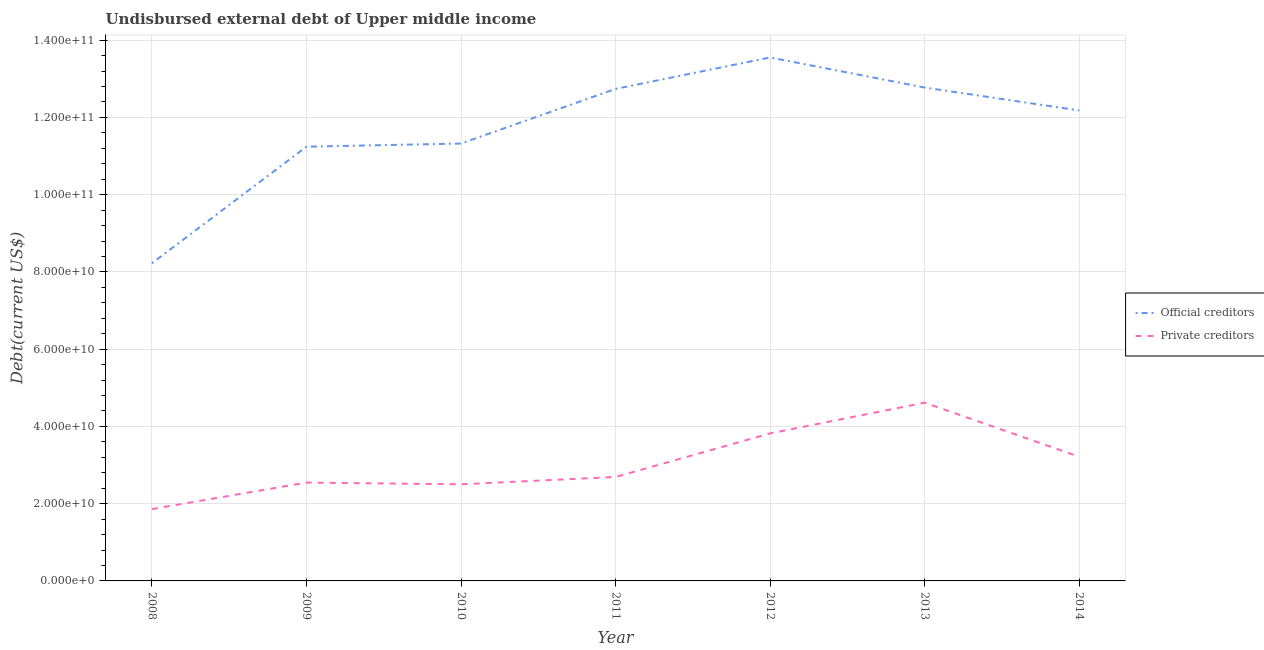What is the undisbursed external debt of official creditors in 2009?
Give a very brief answer. 1.12e+11. Across all years, what is the maximum undisbursed external debt of official creditors?
Offer a very short reply. 1.36e+11. Across all years, what is the minimum undisbursed external debt of private creditors?
Provide a short and direct response. 1.86e+1. In which year was the undisbursed external debt of official creditors maximum?
Your response must be concise. 2012. In which year was the undisbursed external debt of official creditors minimum?
Provide a succinct answer. 2008. What is the total undisbursed external debt of official creditors in the graph?
Give a very brief answer. 8.20e+11. What is the difference between the undisbursed external debt of official creditors in 2009 and that in 2013?
Make the answer very short. -1.53e+1. What is the difference between the undisbursed external debt of official creditors in 2012 and the undisbursed external debt of private creditors in 2008?
Your answer should be very brief. 1.17e+11. What is the average undisbursed external debt of private creditors per year?
Your response must be concise. 3.04e+1. In the year 2010, what is the difference between the undisbursed external debt of official creditors and undisbursed external debt of private creditors?
Your answer should be very brief. 8.82e+1. In how many years, is the undisbursed external debt of private creditors greater than 96000000000 US$?
Provide a short and direct response. 0. What is the ratio of the undisbursed external debt of official creditors in 2010 to that in 2014?
Offer a very short reply. 0.93. Is the difference between the undisbursed external debt of official creditors in 2011 and 2012 greater than the difference between the undisbursed external debt of private creditors in 2011 and 2012?
Ensure brevity in your answer.  Yes. What is the difference between the highest and the second highest undisbursed external debt of official creditors?
Ensure brevity in your answer.  7.79e+09. What is the difference between the highest and the lowest undisbursed external debt of official creditors?
Ensure brevity in your answer.  5.33e+1. Is the undisbursed external debt of official creditors strictly greater than the undisbursed external debt of private creditors over the years?
Keep it short and to the point. Yes. How many lines are there?
Your answer should be very brief. 2. How many years are there in the graph?
Make the answer very short. 7. What is the difference between two consecutive major ticks on the Y-axis?
Keep it short and to the point. 2.00e+1. Does the graph contain any zero values?
Make the answer very short. No. Does the graph contain grids?
Offer a very short reply. Yes. Where does the legend appear in the graph?
Your answer should be very brief. Center right. What is the title of the graph?
Your answer should be very brief. Undisbursed external debt of Upper middle income. What is the label or title of the X-axis?
Your answer should be very brief. Year. What is the label or title of the Y-axis?
Give a very brief answer. Debt(current US$). What is the Debt(current US$) in Official creditors in 2008?
Ensure brevity in your answer.  8.22e+1. What is the Debt(current US$) in Private creditors in 2008?
Your answer should be compact. 1.86e+1. What is the Debt(current US$) of Official creditors in 2009?
Offer a very short reply. 1.12e+11. What is the Debt(current US$) in Private creditors in 2009?
Your response must be concise. 2.55e+1. What is the Debt(current US$) of Official creditors in 2010?
Ensure brevity in your answer.  1.13e+11. What is the Debt(current US$) in Private creditors in 2010?
Keep it short and to the point. 2.50e+1. What is the Debt(current US$) in Official creditors in 2011?
Provide a short and direct response. 1.27e+11. What is the Debt(current US$) in Private creditors in 2011?
Provide a short and direct response. 2.69e+1. What is the Debt(current US$) in Official creditors in 2012?
Your answer should be compact. 1.36e+11. What is the Debt(current US$) of Private creditors in 2012?
Your response must be concise. 3.82e+1. What is the Debt(current US$) in Official creditors in 2013?
Offer a very short reply. 1.28e+11. What is the Debt(current US$) in Private creditors in 2013?
Your answer should be very brief. 4.62e+1. What is the Debt(current US$) of Official creditors in 2014?
Make the answer very short. 1.22e+11. What is the Debt(current US$) in Private creditors in 2014?
Offer a very short reply. 3.21e+1. Across all years, what is the maximum Debt(current US$) in Official creditors?
Provide a succinct answer. 1.36e+11. Across all years, what is the maximum Debt(current US$) of Private creditors?
Your response must be concise. 4.62e+1. Across all years, what is the minimum Debt(current US$) in Official creditors?
Your response must be concise. 8.22e+1. Across all years, what is the minimum Debt(current US$) of Private creditors?
Give a very brief answer. 1.86e+1. What is the total Debt(current US$) in Official creditors in the graph?
Your response must be concise. 8.20e+11. What is the total Debt(current US$) of Private creditors in the graph?
Your response must be concise. 2.12e+11. What is the difference between the Debt(current US$) of Official creditors in 2008 and that in 2009?
Provide a short and direct response. -3.02e+1. What is the difference between the Debt(current US$) in Private creditors in 2008 and that in 2009?
Offer a terse response. -6.85e+09. What is the difference between the Debt(current US$) in Official creditors in 2008 and that in 2010?
Ensure brevity in your answer.  -3.10e+1. What is the difference between the Debt(current US$) of Private creditors in 2008 and that in 2010?
Offer a very short reply. -6.41e+09. What is the difference between the Debt(current US$) of Official creditors in 2008 and that in 2011?
Offer a terse response. -4.51e+1. What is the difference between the Debt(current US$) of Private creditors in 2008 and that in 2011?
Give a very brief answer. -8.31e+09. What is the difference between the Debt(current US$) in Official creditors in 2008 and that in 2012?
Ensure brevity in your answer.  -5.33e+1. What is the difference between the Debt(current US$) in Private creditors in 2008 and that in 2012?
Your answer should be compact. -1.96e+1. What is the difference between the Debt(current US$) in Official creditors in 2008 and that in 2013?
Keep it short and to the point. -4.55e+1. What is the difference between the Debt(current US$) in Private creditors in 2008 and that in 2013?
Provide a succinct answer. -2.75e+1. What is the difference between the Debt(current US$) in Official creditors in 2008 and that in 2014?
Keep it short and to the point. -3.96e+1. What is the difference between the Debt(current US$) of Private creditors in 2008 and that in 2014?
Your answer should be compact. -1.35e+1. What is the difference between the Debt(current US$) of Official creditors in 2009 and that in 2010?
Offer a terse response. -8.15e+08. What is the difference between the Debt(current US$) in Private creditors in 2009 and that in 2010?
Provide a short and direct response. 4.37e+08. What is the difference between the Debt(current US$) of Official creditors in 2009 and that in 2011?
Make the answer very short. -1.50e+1. What is the difference between the Debt(current US$) in Private creditors in 2009 and that in 2011?
Offer a very short reply. -1.46e+09. What is the difference between the Debt(current US$) in Official creditors in 2009 and that in 2012?
Offer a very short reply. -2.31e+1. What is the difference between the Debt(current US$) of Private creditors in 2009 and that in 2012?
Keep it short and to the point. -1.27e+1. What is the difference between the Debt(current US$) in Official creditors in 2009 and that in 2013?
Your response must be concise. -1.53e+1. What is the difference between the Debt(current US$) of Private creditors in 2009 and that in 2013?
Ensure brevity in your answer.  -2.07e+1. What is the difference between the Debt(current US$) of Official creditors in 2009 and that in 2014?
Provide a succinct answer. -9.39e+09. What is the difference between the Debt(current US$) of Private creditors in 2009 and that in 2014?
Provide a succinct answer. -6.69e+09. What is the difference between the Debt(current US$) in Official creditors in 2010 and that in 2011?
Offer a terse response. -1.41e+1. What is the difference between the Debt(current US$) of Private creditors in 2010 and that in 2011?
Offer a terse response. -1.89e+09. What is the difference between the Debt(current US$) of Official creditors in 2010 and that in 2012?
Make the answer very short. -2.23e+1. What is the difference between the Debt(current US$) in Private creditors in 2010 and that in 2012?
Offer a very short reply. -1.32e+1. What is the difference between the Debt(current US$) in Official creditors in 2010 and that in 2013?
Ensure brevity in your answer.  -1.45e+1. What is the difference between the Debt(current US$) of Private creditors in 2010 and that in 2013?
Your answer should be compact. -2.11e+1. What is the difference between the Debt(current US$) of Official creditors in 2010 and that in 2014?
Give a very brief answer. -8.57e+09. What is the difference between the Debt(current US$) in Private creditors in 2010 and that in 2014?
Your response must be concise. -7.12e+09. What is the difference between the Debt(current US$) in Official creditors in 2011 and that in 2012?
Provide a short and direct response. -8.14e+09. What is the difference between the Debt(current US$) in Private creditors in 2011 and that in 2012?
Provide a succinct answer. -1.13e+1. What is the difference between the Debt(current US$) of Official creditors in 2011 and that in 2013?
Your response must be concise. -3.50e+08. What is the difference between the Debt(current US$) of Private creditors in 2011 and that in 2013?
Keep it short and to the point. -1.92e+1. What is the difference between the Debt(current US$) of Official creditors in 2011 and that in 2014?
Your answer should be very brief. 5.58e+09. What is the difference between the Debt(current US$) in Private creditors in 2011 and that in 2014?
Your response must be concise. -5.23e+09. What is the difference between the Debt(current US$) of Official creditors in 2012 and that in 2013?
Your answer should be compact. 7.79e+09. What is the difference between the Debt(current US$) of Private creditors in 2012 and that in 2013?
Make the answer very short. -7.95e+09. What is the difference between the Debt(current US$) of Official creditors in 2012 and that in 2014?
Provide a short and direct response. 1.37e+1. What is the difference between the Debt(current US$) in Private creditors in 2012 and that in 2014?
Provide a succinct answer. 6.05e+09. What is the difference between the Debt(current US$) in Official creditors in 2013 and that in 2014?
Offer a very short reply. 5.93e+09. What is the difference between the Debt(current US$) of Private creditors in 2013 and that in 2014?
Offer a terse response. 1.40e+1. What is the difference between the Debt(current US$) of Official creditors in 2008 and the Debt(current US$) of Private creditors in 2009?
Keep it short and to the point. 5.68e+1. What is the difference between the Debt(current US$) of Official creditors in 2008 and the Debt(current US$) of Private creditors in 2010?
Provide a short and direct response. 5.72e+1. What is the difference between the Debt(current US$) of Official creditors in 2008 and the Debt(current US$) of Private creditors in 2011?
Your answer should be compact. 5.53e+1. What is the difference between the Debt(current US$) of Official creditors in 2008 and the Debt(current US$) of Private creditors in 2012?
Give a very brief answer. 4.40e+1. What is the difference between the Debt(current US$) of Official creditors in 2008 and the Debt(current US$) of Private creditors in 2013?
Keep it short and to the point. 3.61e+1. What is the difference between the Debt(current US$) in Official creditors in 2008 and the Debt(current US$) in Private creditors in 2014?
Offer a very short reply. 5.01e+1. What is the difference between the Debt(current US$) of Official creditors in 2009 and the Debt(current US$) of Private creditors in 2010?
Your response must be concise. 8.74e+1. What is the difference between the Debt(current US$) in Official creditors in 2009 and the Debt(current US$) in Private creditors in 2011?
Your answer should be very brief. 8.55e+1. What is the difference between the Debt(current US$) of Official creditors in 2009 and the Debt(current US$) of Private creditors in 2012?
Your answer should be compact. 7.42e+1. What is the difference between the Debt(current US$) in Official creditors in 2009 and the Debt(current US$) in Private creditors in 2013?
Give a very brief answer. 6.63e+1. What is the difference between the Debt(current US$) of Official creditors in 2009 and the Debt(current US$) of Private creditors in 2014?
Give a very brief answer. 8.03e+1. What is the difference between the Debt(current US$) in Official creditors in 2010 and the Debt(current US$) in Private creditors in 2011?
Offer a very short reply. 8.63e+1. What is the difference between the Debt(current US$) of Official creditors in 2010 and the Debt(current US$) of Private creditors in 2012?
Give a very brief answer. 7.50e+1. What is the difference between the Debt(current US$) of Official creditors in 2010 and the Debt(current US$) of Private creditors in 2013?
Ensure brevity in your answer.  6.71e+1. What is the difference between the Debt(current US$) of Official creditors in 2010 and the Debt(current US$) of Private creditors in 2014?
Your answer should be compact. 8.11e+1. What is the difference between the Debt(current US$) of Official creditors in 2011 and the Debt(current US$) of Private creditors in 2012?
Offer a terse response. 8.92e+1. What is the difference between the Debt(current US$) in Official creditors in 2011 and the Debt(current US$) in Private creditors in 2013?
Ensure brevity in your answer.  8.12e+1. What is the difference between the Debt(current US$) in Official creditors in 2011 and the Debt(current US$) in Private creditors in 2014?
Provide a short and direct response. 9.52e+1. What is the difference between the Debt(current US$) in Official creditors in 2012 and the Debt(current US$) in Private creditors in 2013?
Your response must be concise. 8.94e+1. What is the difference between the Debt(current US$) of Official creditors in 2012 and the Debt(current US$) of Private creditors in 2014?
Your response must be concise. 1.03e+11. What is the difference between the Debt(current US$) of Official creditors in 2013 and the Debt(current US$) of Private creditors in 2014?
Offer a terse response. 9.56e+1. What is the average Debt(current US$) of Official creditors per year?
Your answer should be very brief. 1.17e+11. What is the average Debt(current US$) of Private creditors per year?
Ensure brevity in your answer.  3.04e+1. In the year 2008, what is the difference between the Debt(current US$) of Official creditors and Debt(current US$) of Private creditors?
Keep it short and to the point. 6.36e+1. In the year 2009, what is the difference between the Debt(current US$) in Official creditors and Debt(current US$) in Private creditors?
Ensure brevity in your answer.  8.70e+1. In the year 2010, what is the difference between the Debt(current US$) of Official creditors and Debt(current US$) of Private creditors?
Keep it short and to the point. 8.82e+1. In the year 2011, what is the difference between the Debt(current US$) in Official creditors and Debt(current US$) in Private creditors?
Offer a very short reply. 1.00e+11. In the year 2012, what is the difference between the Debt(current US$) of Official creditors and Debt(current US$) of Private creditors?
Give a very brief answer. 9.73e+1. In the year 2013, what is the difference between the Debt(current US$) of Official creditors and Debt(current US$) of Private creditors?
Offer a very short reply. 8.16e+1. In the year 2014, what is the difference between the Debt(current US$) in Official creditors and Debt(current US$) in Private creditors?
Provide a short and direct response. 8.97e+1. What is the ratio of the Debt(current US$) of Official creditors in 2008 to that in 2009?
Provide a succinct answer. 0.73. What is the ratio of the Debt(current US$) of Private creditors in 2008 to that in 2009?
Provide a short and direct response. 0.73. What is the ratio of the Debt(current US$) in Official creditors in 2008 to that in 2010?
Keep it short and to the point. 0.73. What is the ratio of the Debt(current US$) of Private creditors in 2008 to that in 2010?
Provide a short and direct response. 0.74. What is the ratio of the Debt(current US$) in Official creditors in 2008 to that in 2011?
Provide a succinct answer. 0.65. What is the ratio of the Debt(current US$) in Private creditors in 2008 to that in 2011?
Offer a terse response. 0.69. What is the ratio of the Debt(current US$) of Official creditors in 2008 to that in 2012?
Provide a succinct answer. 0.61. What is the ratio of the Debt(current US$) of Private creditors in 2008 to that in 2012?
Your answer should be very brief. 0.49. What is the ratio of the Debt(current US$) of Official creditors in 2008 to that in 2013?
Offer a terse response. 0.64. What is the ratio of the Debt(current US$) of Private creditors in 2008 to that in 2013?
Give a very brief answer. 0.4. What is the ratio of the Debt(current US$) in Official creditors in 2008 to that in 2014?
Provide a short and direct response. 0.68. What is the ratio of the Debt(current US$) in Private creditors in 2008 to that in 2014?
Keep it short and to the point. 0.58. What is the ratio of the Debt(current US$) of Private creditors in 2009 to that in 2010?
Ensure brevity in your answer.  1.02. What is the ratio of the Debt(current US$) in Official creditors in 2009 to that in 2011?
Provide a short and direct response. 0.88. What is the ratio of the Debt(current US$) of Private creditors in 2009 to that in 2011?
Your response must be concise. 0.95. What is the ratio of the Debt(current US$) of Official creditors in 2009 to that in 2012?
Provide a short and direct response. 0.83. What is the ratio of the Debt(current US$) in Private creditors in 2009 to that in 2012?
Keep it short and to the point. 0.67. What is the ratio of the Debt(current US$) in Official creditors in 2009 to that in 2013?
Ensure brevity in your answer.  0.88. What is the ratio of the Debt(current US$) of Private creditors in 2009 to that in 2013?
Ensure brevity in your answer.  0.55. What is the ratio of the Debt(current US$) in Official creditors in 2009 to that in 2014?
Make the answer very short. 0.92. What is the ratio of the Debt(current US$) of Private creditors in 2009 to that in 2014?
Give a very brief answer. 0.79. What is the ratio of the Debt(current US$) in Official creditors in 2010 to that in 2011?
Provide a succinct answer. 0.89. What is the ratio of the Debt(current US$) in Private creditors in 2010 to that in 2011?
Provide a succinct answer. 0.93. What is the ratio of the Debt(current US$) of Official creditors in 2010 to that in 2012?
Offer a very short reply. 0.84. What is the ratio of the Debt(current US$) of Private creditors in 2010 to that in 2012?
Your answer should be compact. 0.66. What is the ratio of the Debt(current US$) in Official creditors in 2010 to that in 2013?
Provide a short and direct response. 0.89. What is the ratio of the Debt(current US$) in Private creditors in 2010 to that in 2013?
Your response must be concise. 0.54. What is the ratio of the Debt(current US$) of Official creditors in 2010 to that in 2014?
Provide a succinct answer. 0.93. What is the ratio of the Debt(current US$) of Private creditors in 2010 to that in 2014?
Provide a short and direct response. 0.78. What is the ratio of the Debt(current US$) in Official creditors in 2011 to that in 2012?
Your answer should be very brief. 0.94. What is the ratio of the Debt(current US$) in Private creditors in 2011 to that in 2012?
Provide a succinct answer. 0.7. What is the ratio of the Debt(current US$) in Private creditors in 2011 to that in 2013?
Your answer should be compact. 0.58. What is the ratio of the Debt(current US$) in Official creditors in 2011 to that in 2014?
Keep it short and to the point. 1.05. What is the ratio of the Debt(current US$) in Private creditors in 2011 to that in 2014?
Your answer should be compact. 0.84. What is the ratio of the Debt(current US$) of Official creditors in 2012 to that in 2013?
Ensure brevity in your answer.  1.06. What is the ratio of the Debt(current US$) in Private creditors in 2012 to that in 2013?
Your response must be concise. 0.83. What is the ratio of the Debt(current US$) in Official creditors in 2012 to that in 2014?
Make the answer very short. 1.11. What is the ratio of the Debt(current US$) of Private creditors in 2012 to that in 2014?
Offer a very short reply. 1.19. What is the ratio of the Debt(current US$) of Official creditors in 2013 to that in 2014?
Provide a short and direct response. 1.05. What is the ratio of the Debt(current US$) of Private creditors in 2013 to that in 2014?
Give a very brief answer. 1.44. What is the difference between the highest and the second highest Debt(current US$) in Official creditors?
Provide a succinct answer. 7.79e+09. What is the difference between the highest and the second highest Debt(current US$) of Private creditors?
Ensure brevity in your answer.  7.95e+09. What is the difference between the highest and the lowest Debt(current US$) in Official creditors?
Give a very brief answer. 5.33e+1. What is the difference between the highest and the lowest Debt(current US$) of Private creditors?
Your response must be concise. 2.75e+1. 